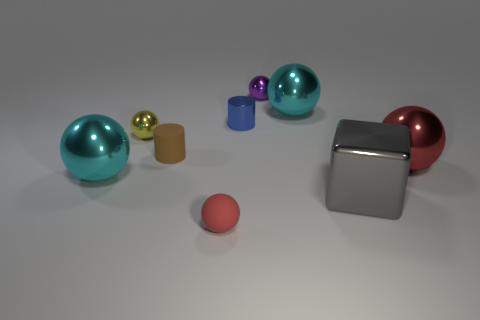Why might someone create an image with such objects? An image like this could be created for several reasons. It may serve as a visualization for teaching purposes, such as explaining geometric shapes, the physics of light and materials, or as a test rendering to showcase the capabilities of a 3D modeling software. It might also be designed for aesthetic purposes or to evoke curiosity by its abstract composition. 